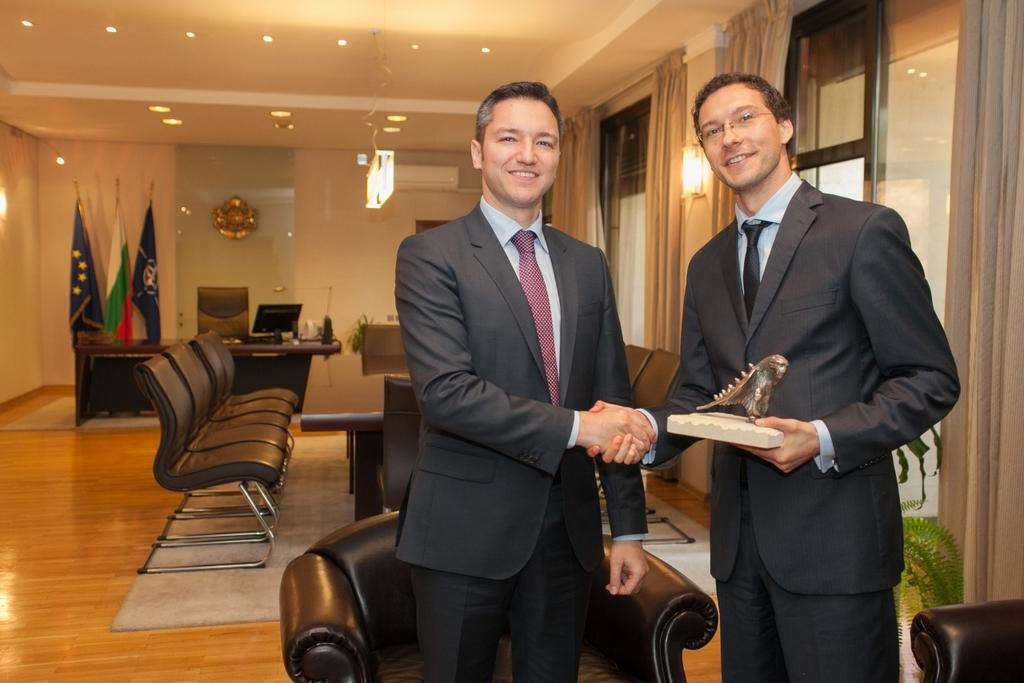How many people are in the image? There are two men in the image. What type of furniture is present in the image? There are chairs and a table in the image. What electronic device is visible in the image? There is a monitor in the image. How many flags are in the image? There are three flags in the image. What type of window treatment is present in the image? There are curtains on the window in the image. What type of history can be seen in the image? There is no specific historical event or reference visible in the image. Are the men in the image crying? There is no indication in the image that the men are crying. 